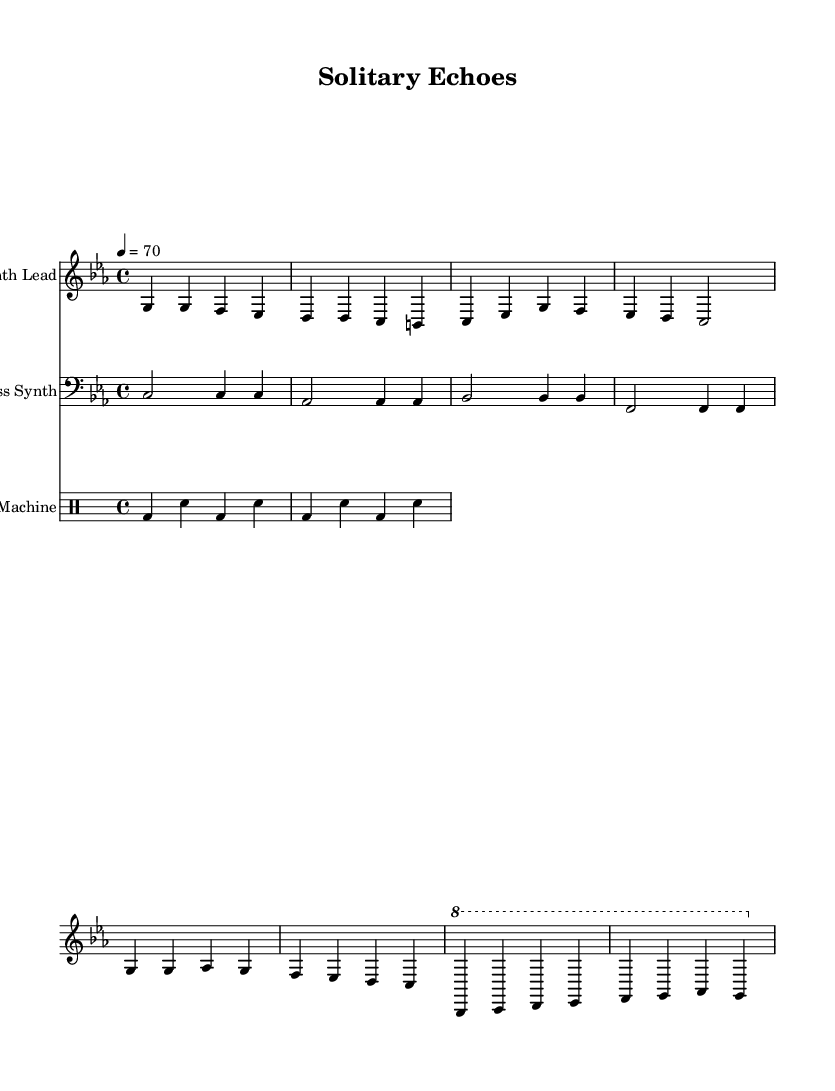What is the key signature of this music? The key signature is C minor, which contains three flats (B♭, E♭, A♭). This can be identified in the music sheet where the key signature is placed at the beginning of the staff.
Answer: C minor What is the time signature of this music? The time signature is 4/4, indicated by the fraction at the beginning of the sheet music. This means there are four beats in every measure, with the quarter note receiving one beat.
Answer: 4/4 What is the tempo marking for this composition? The tempo marking in the music states "4 = 70", indicating that there are 70 beats per minute, with each beat represented by a quarter note. This is typically found near the beginning of the score.
Answer: 70 How many measures are in the "Intro" section? The Intro section consists of two measures, as can be counted from the notation of the synth lead, where each bar corresponds to a measure indicated by vertical lines.
Answer: 2 What type of synth is mainly used in this composition? The music sheet identifies the primary voice as "Synth Lead," which suggests that this is an electronic composition where synthesizers are the main instruments. This is explicitly mentioned in the staff label at the beginning.
Answer: Synth Lead What is the rhythmic pattern of the drum machine? The drum machine follows a bass drum (bd) and snare pattern repeating every two measures. Each measure has a structure of bass and snare, suggesting a steady beat typical of electronic music.
Answer: bd sn Which section features an octave shift? The "Bridge" section features an octave shift, as indicated by the \ottava command in the score, which raises the pitches of the notes by one octave in the first part of that section. This creates a distinct sound different from the verses.
Answer: Bridge 